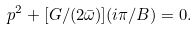<formula> <loc_0><loc_0><loc_500><loc_500>p ^ { 2 } + [ G / ( 2 \bar { \omega } ) ] ( i \pi / B ) = 0 .</formula> 